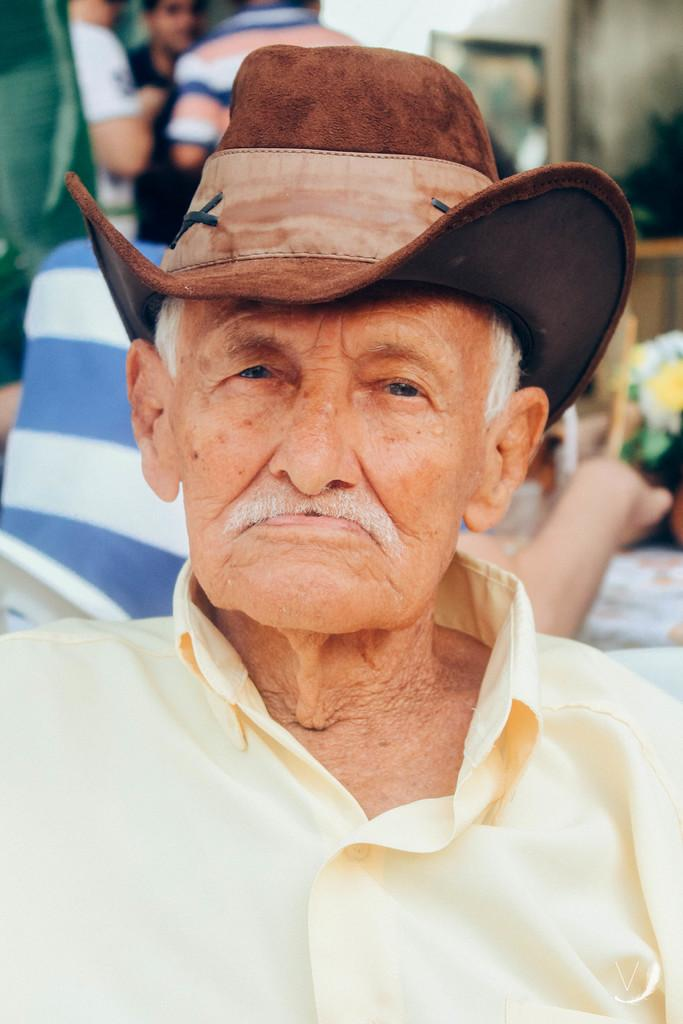What is the main subject in the center of the image? There is a person wearing a hat in the center of the image. Can you describe the surroundings of the person? There are other people and objects visible in the background of the image. What type of holiday is being celebrated in the image? There is no indication of a holiday being celebrated in the image. Can you see a bear interacting with the person wearing a hat in the image? There is no bear present in the image. 